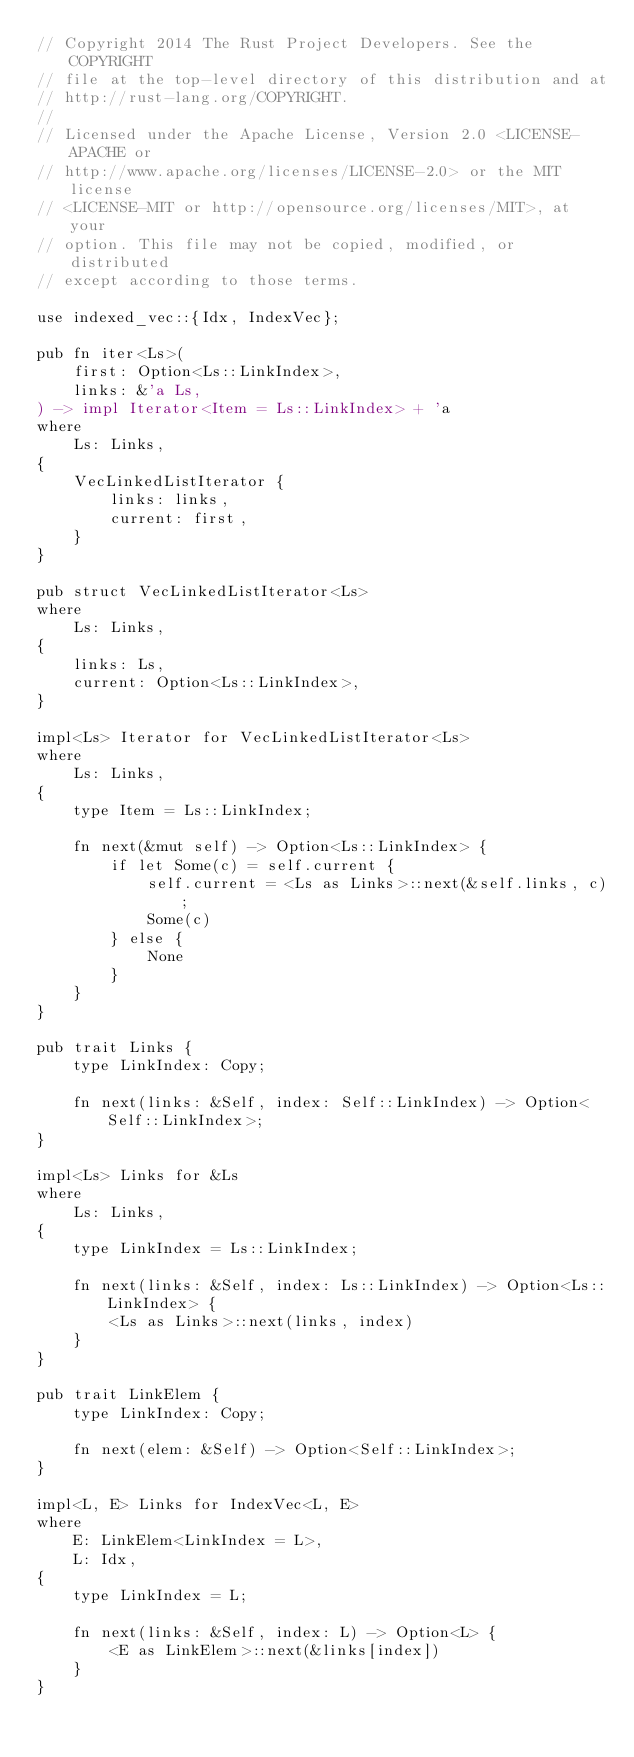<code> <loc_0><loc_0><loc_500><loc_500><_Rust_>// Copyright 2014 The Rust Project Developers. See the COPYRIGHT
// file at the top-level directory of this distribution and at
// http://rust-lang.org/COPYRIGHT.
//
// Licensed under the Apache License, Version 2.0 <LICENSE-APACHE or
// http://www.apache.org/licenses/LICENSE-2.0> or the MIT license
// <LICENSE-MIT or http://opensource.org/licenses/MIT>, at your
// option. This file may not be copied, modified, or distributed
// except according to those terms.

use indexed_vec::{Idx, IndexVec};

pub fn iter<Ls>(
    first: Option<Ls::LinkIndex>,
    links: &'a Ls,
) -> impl Iterator<Item = Ls::LinkIndex> + 'a
where
    Ls: Links,
{
    VecLinkedListIterator {
        links: links,
        current: first,
    }
}

pub struct VecLinkedListIterator<Ls>
where
    Ls: Links,
{
    links: Ls,
    current: Option<Ls::LinkIndex>,
}

impl<Ls> Iterator for VecLinkedListIterator<Ls>
where
    Ls: Links,
{
    type Item = Ls::LinkIndex;

    fn next(&mut self) -> Option<Ls::LinkIndex> {
        if let Some(c) = self.current {
            self.current = <Ls as Links>::next(&self.links, c);
            Some(c)
        } else {
            None
        }
    }
}

pub trait Links {
    type LinkIndex: Copy;

    fn next(links: &Self, index: Self::LinkIndex) -> Option<Self::LinkIndex>;
}

impl<Ls> Links for &Ls
where
    Ls: Links,
{
    type LinkIndex = Ls::LinkIndex;

    fn next(links: &Self, index: Ls::LinkIndex) -> Option<Ls::LinkIndex> {
        <Ls as Links>::next(links, index)
    }
}

pub trait LinkElem {
    type LinkIndex: Copy;

    fn next(elem: &Self) -> Option<Self::LinkIndex>;
}

impl<L, E> Links for IndexVec<L, E>
where
    E: LinkElem<LinkIndex = L>,
    L: Idx,
{
    type LinkIndex = L;

    fn next(links: &Self, index: L) -> Option<L> {
        <E as LinkElem>::next(&links[index])
    }
}
</code> 